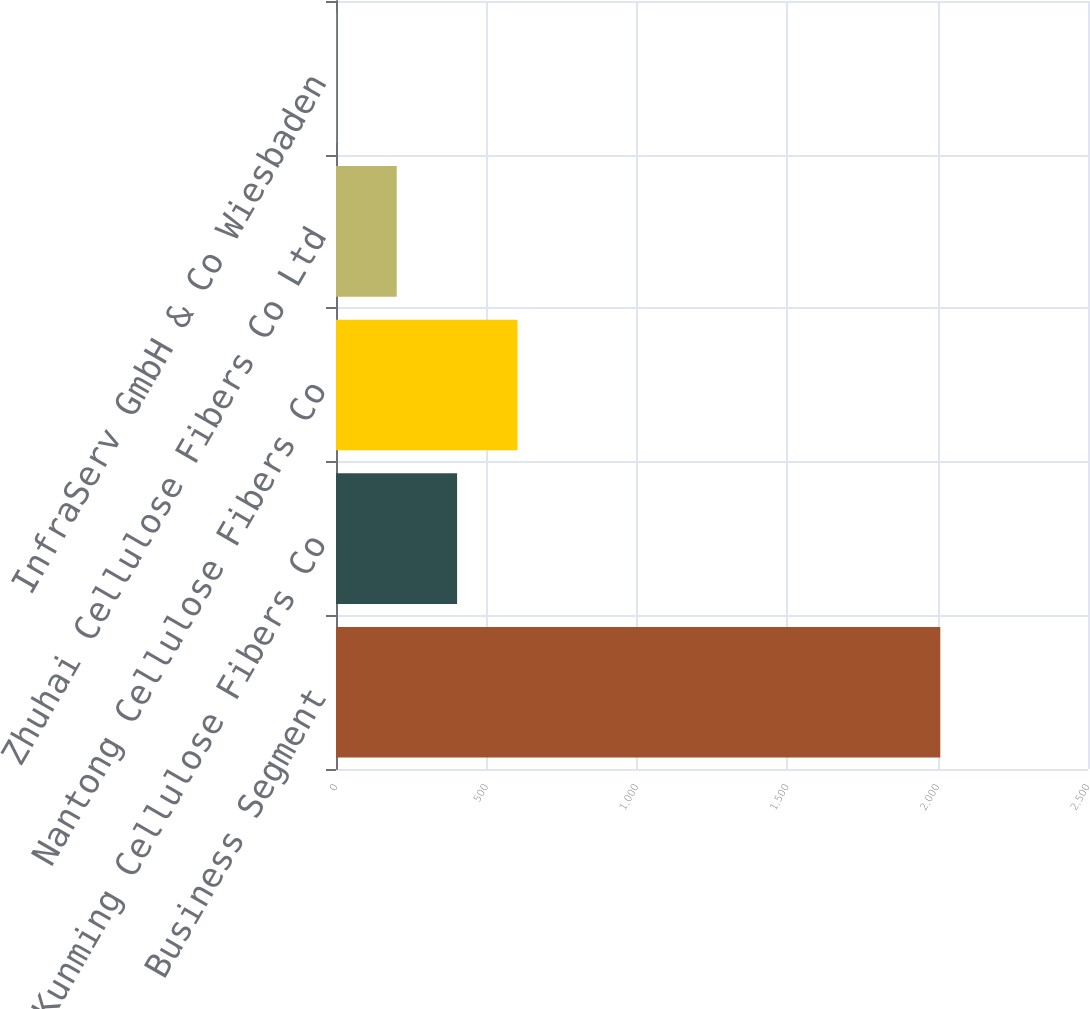Convert chart. <chart><loc_0><loc_0><loc_500><loc_500><bar_chart><fcel>Business Segment<fcel>Kunming Cellulose Fibers Co<fcel>Nantong Cellulose Fibers Co<fcel>Zhuhai Cellulose Fibers Co Ltd<fcel>InfraServ GmbH & Co Wiesbaden<nl><fcel>2009<fcel>402.6<fcel>603.4<fcel>201.8<fcel>1<nl></chart> 